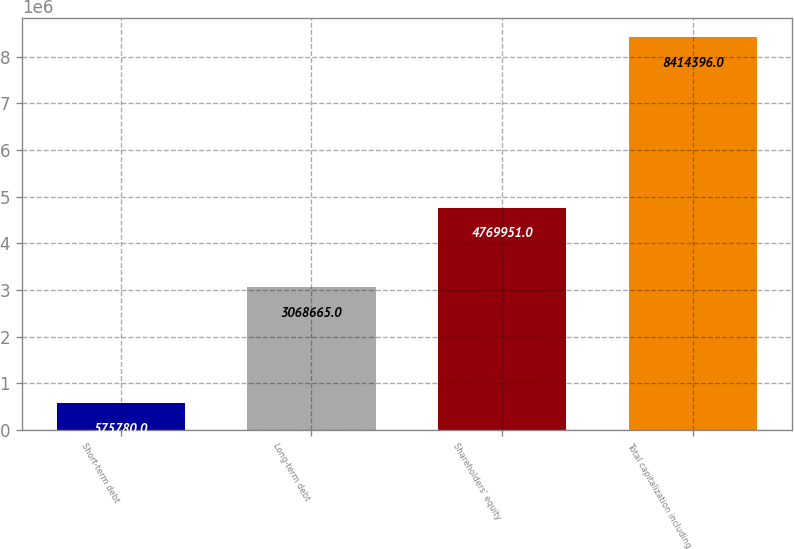Convert chart. <chart><loc_0><loc_0><loc_500><loc_500><bar_chart><fcel>Short-term debt<fcel>Long-term debt<fcel>Shareholders' equity<fcel>Total capitalization including<nl><fcel>575780<fcel>3.06866e+06<fcel>4.76995e+06<fcel>8.4144e+06<nl></chart> 